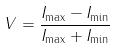<formula> <loc_0><loc_0><loc_500><loc_500>V = \frac { I _ { \max } - I _ { \min } } { I _ { \max } + I _ { \min } }</formula> 